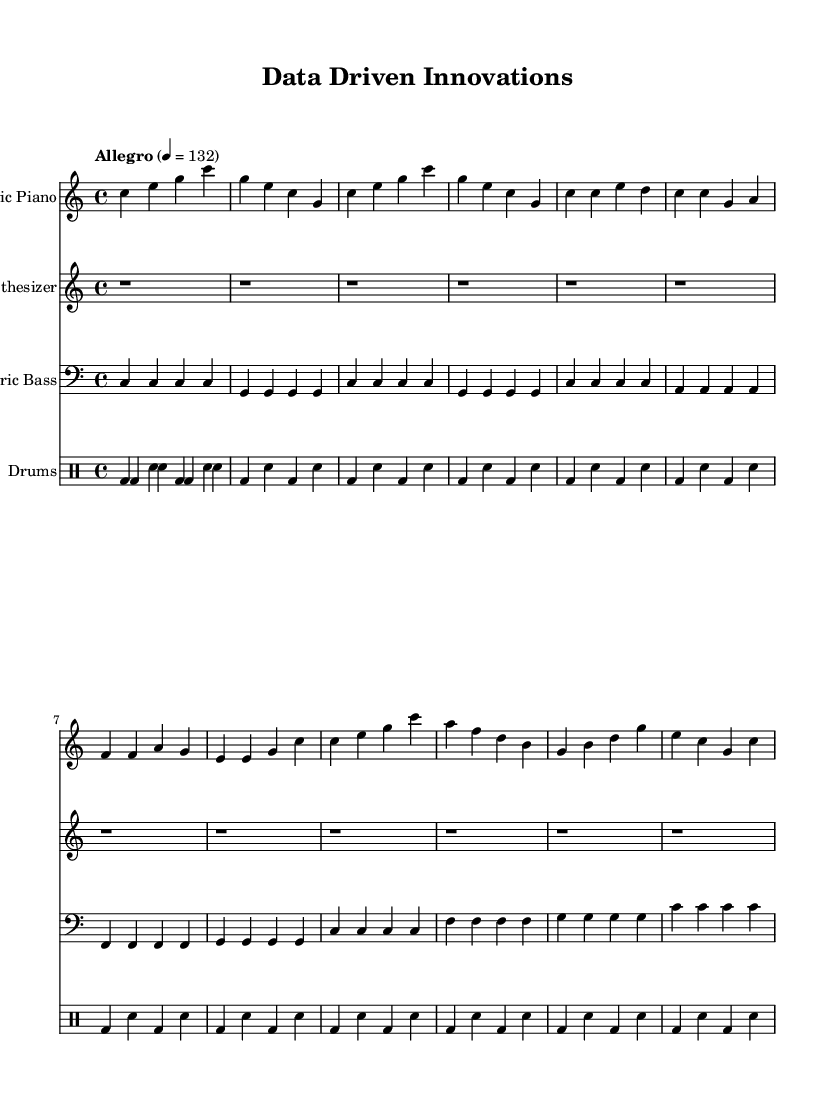What is the key signature of this music? The key signature is C major, which has no sharps or flats, indicated by the absence of accidentals in the music.
Answer: C major What is the time signature of this piece? The time signature is 4/4, which is common time and is indicated at the beginning of the score.
Answer: 4/4 What is the tempo marking for this piece? The tempo marking is "Allegro" indicating a fast, lively pace, with a metronome marking of 132 beats per minute.
Answer: Allegro, 132 How many instruments are featured in this score? There are four instruments indicated: Electric Piano, Synthesizer, Electric Bass, and Drums.
Answer: Four Identify the main section where the melody peaks. The main section where the melody peaks is the Chorus, characterized by a more dynamic and melodically engaging part of the piece.
Answer: Chorus What rhythmic pattern do the drums follow throughout this piece? The drums follow a repeating pattern of bass drum and snare alternating, which creates a driving rhythmic foundation for the track.
Answer: Bass and snare pattern What type of musical work is this piece categorized as? This piece is categorized as a soundtrack, evidenced by its upbeat instrumental theme designed to evoke feelings associated with technological breakthroughs.
Answer: Soundtrack 